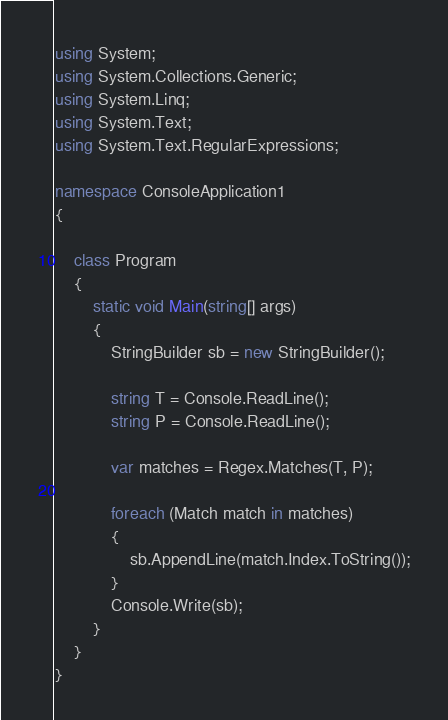Convert code to text. <code><loc_0><loc_0><loc_500><loc_500><_C#_>using System;
using System.Collections.Generic;
using System.Linq;
using System.Text;
using System.Text.RegularExpressions;

namespace ConsoleApplication1
{

    class Program
    {
        static void Main(string[] args)
        {
            StringBuilder sb = new StringBuilder();

            string T = Console.ReadLine();
            string P = Console.ReadLine();

            var matches = Regex.Matches(T, P);

            foreach (Match match in matches)
            {
                sb.AppendLine(match.Index.ToString());
            }
            Console.Write(sb);
        }
    }
}</code> 